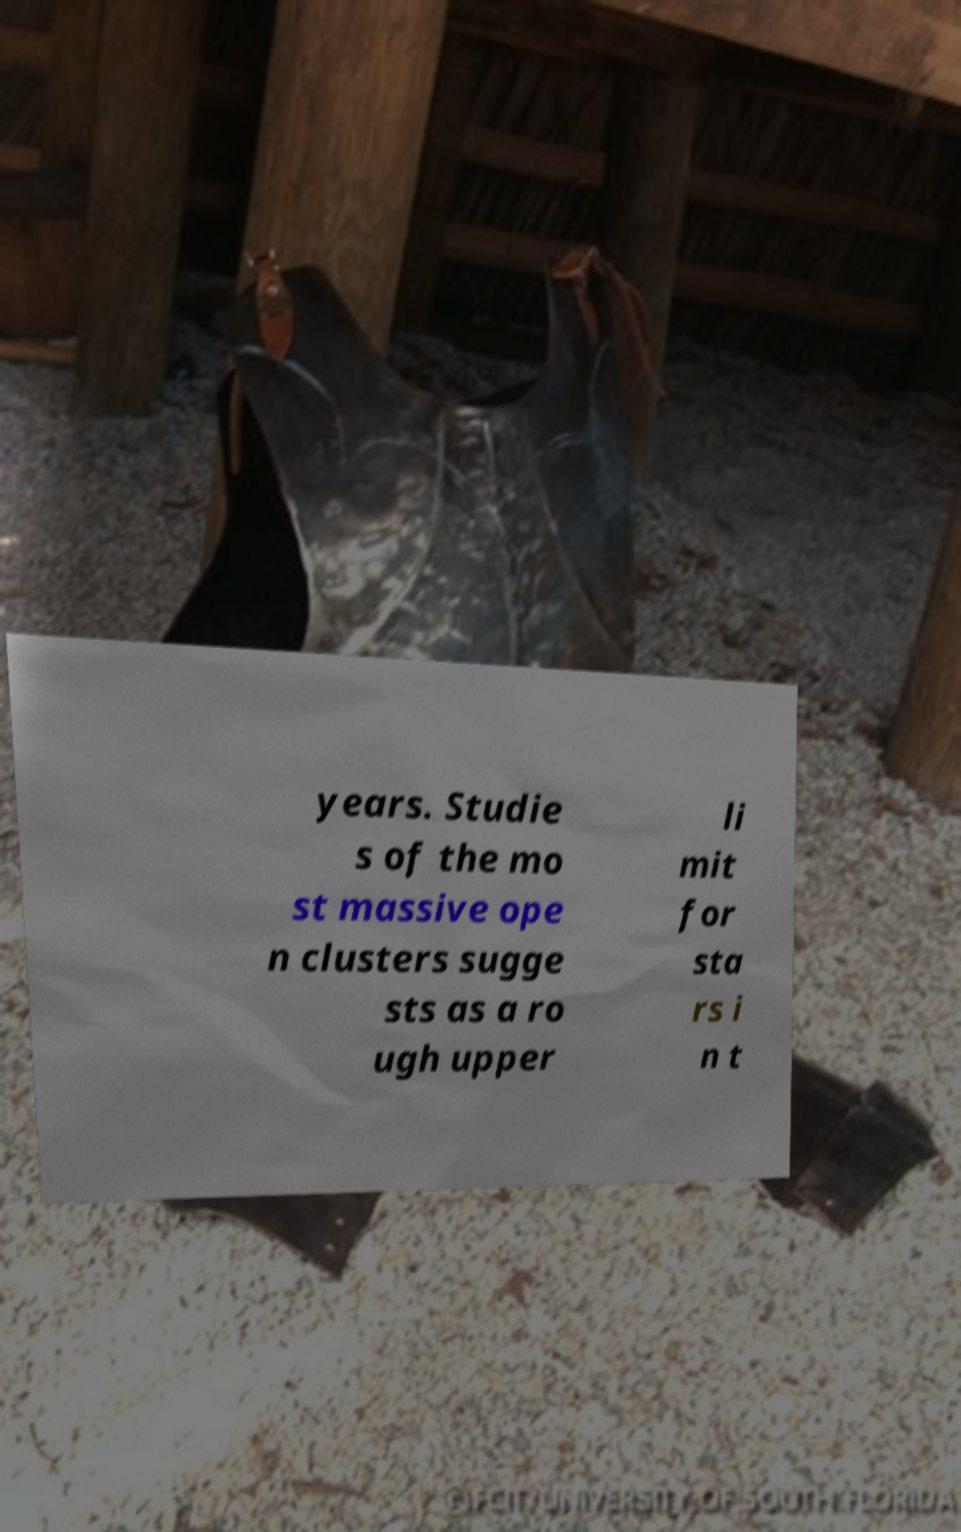Could you extract and type out the text from this image? years. Studie s of the mo st massive ope n clusters sugge sts as a ro ugh upper li mit for sta rs i n t 